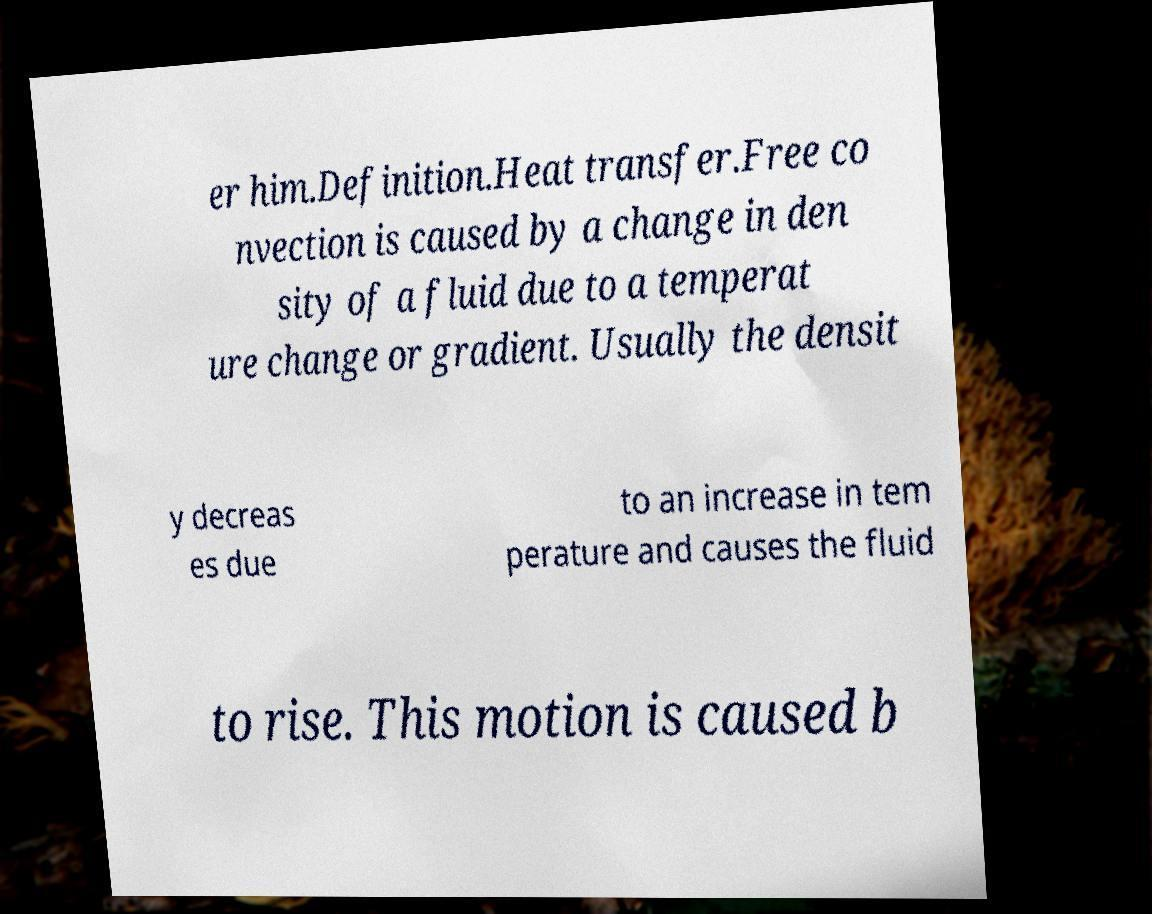Can you accurately transcribe the text from the provided image for me? er him.Definition.Heat transfer.Free co nvection is caused by a change in den sity of a fluid due to a temperat ure change or gradient. Usually the densit y decreas es due to an increase in tem perature and causes the fluid to rise. This motion is caused b 